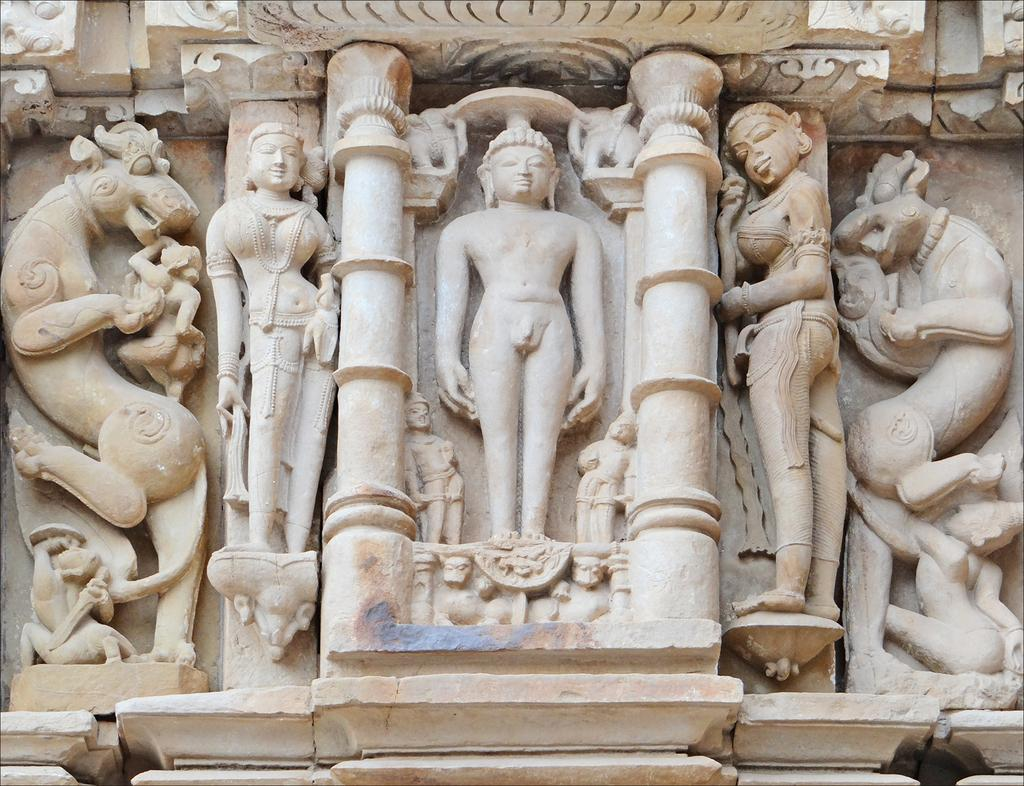What type of objects are in the image? There are sculptures in the image. Where are the sculptures located? The sculptures are on a platform. Can you describe the positioning of the platform? The platform is on the wall. What type of drink can be seen being poured from the roof in the image? There is no drink or roof present in the image; it features sculptures on a platform on the wall. 